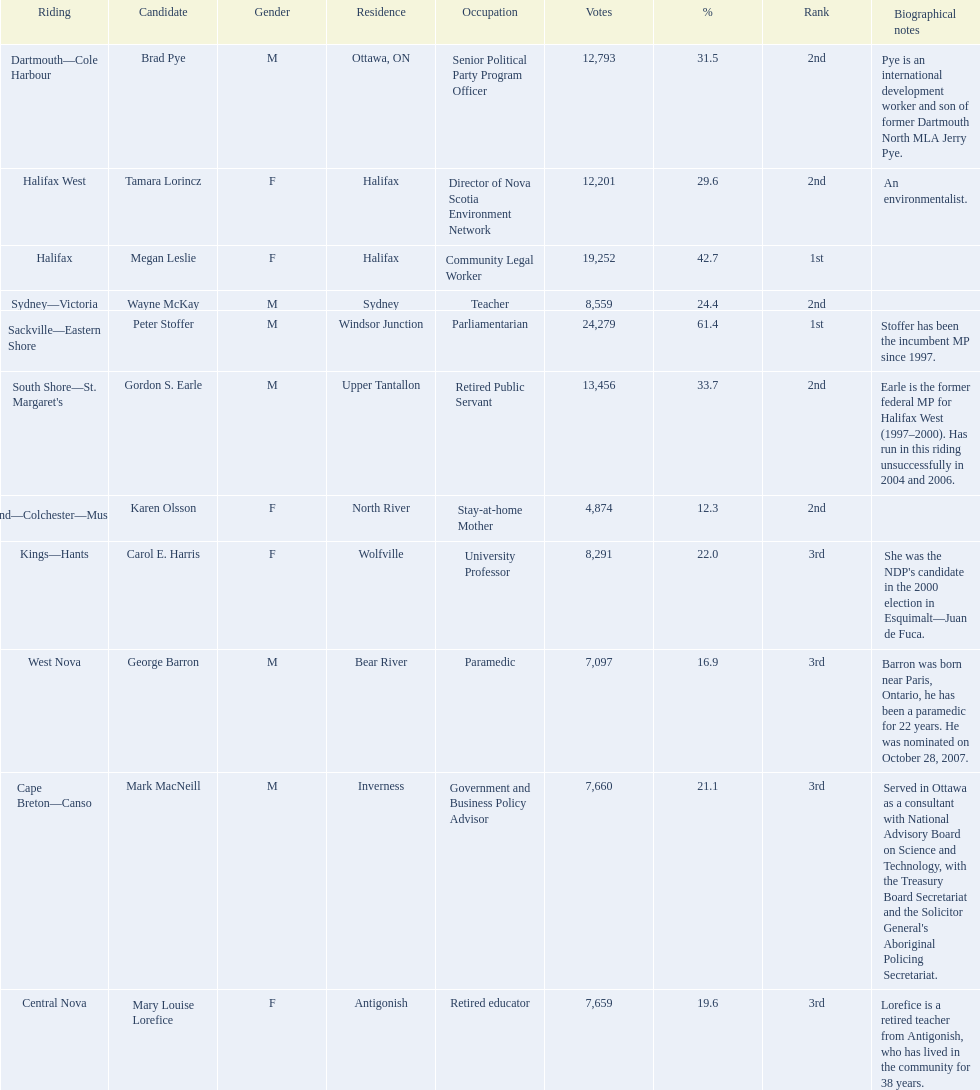Who were the new democratic party candidates, 2008? Mark MacNeill, Mary Louise Lorefice, Karen Olsson, Brad Pye, Megan Leslie, Tamara Lorincz, Carol E. Harris, Peter Stoffer, Gordon S. Earle, Wayne McKay, George Barron. Who had the 2nd highest number of votes? Megan Leslie, Peter Stoffer. How many votes did she receive? 19,252. 